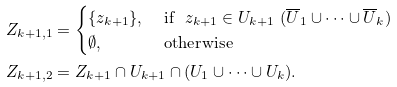<formula> <loc_0><loc_0><loc_500><loc_500>Z _ { k + 1 , 1 } & = \begin{cases} \{ z _ { k + 1 } \} , & \text { if } \ z _ { k + 1 } \in U _ { k + 1 } \ ( \overline { U } _ { 1 } \cup \dots \cup \overline { U } _ { k } ) \\ \emptyset , & \text { otherwise } \end{cases} \\ Z _ { k + 1 , 2 } & = Z _ { k + 1 } \cap U _ { k + 1 } \cap ( U _ { 1 } \cup \dots \cup U _ { k } ) .</formula> 